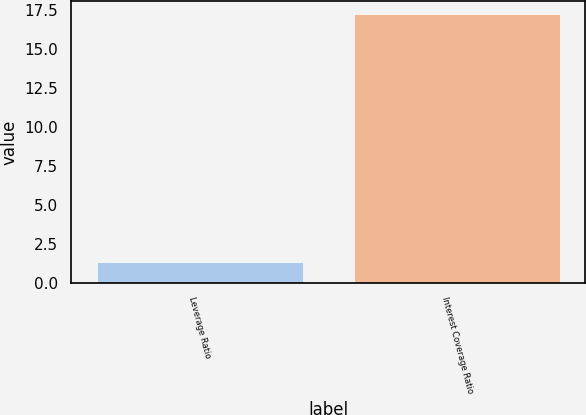<chart> <loc_0><loc_0><loc_500><loc_500><bar_chart><fcel>Leverage Ratio<fcel>Interest Coverage Ratio<nl><fcel>1.34<fcel>17.26<nl></chart> 